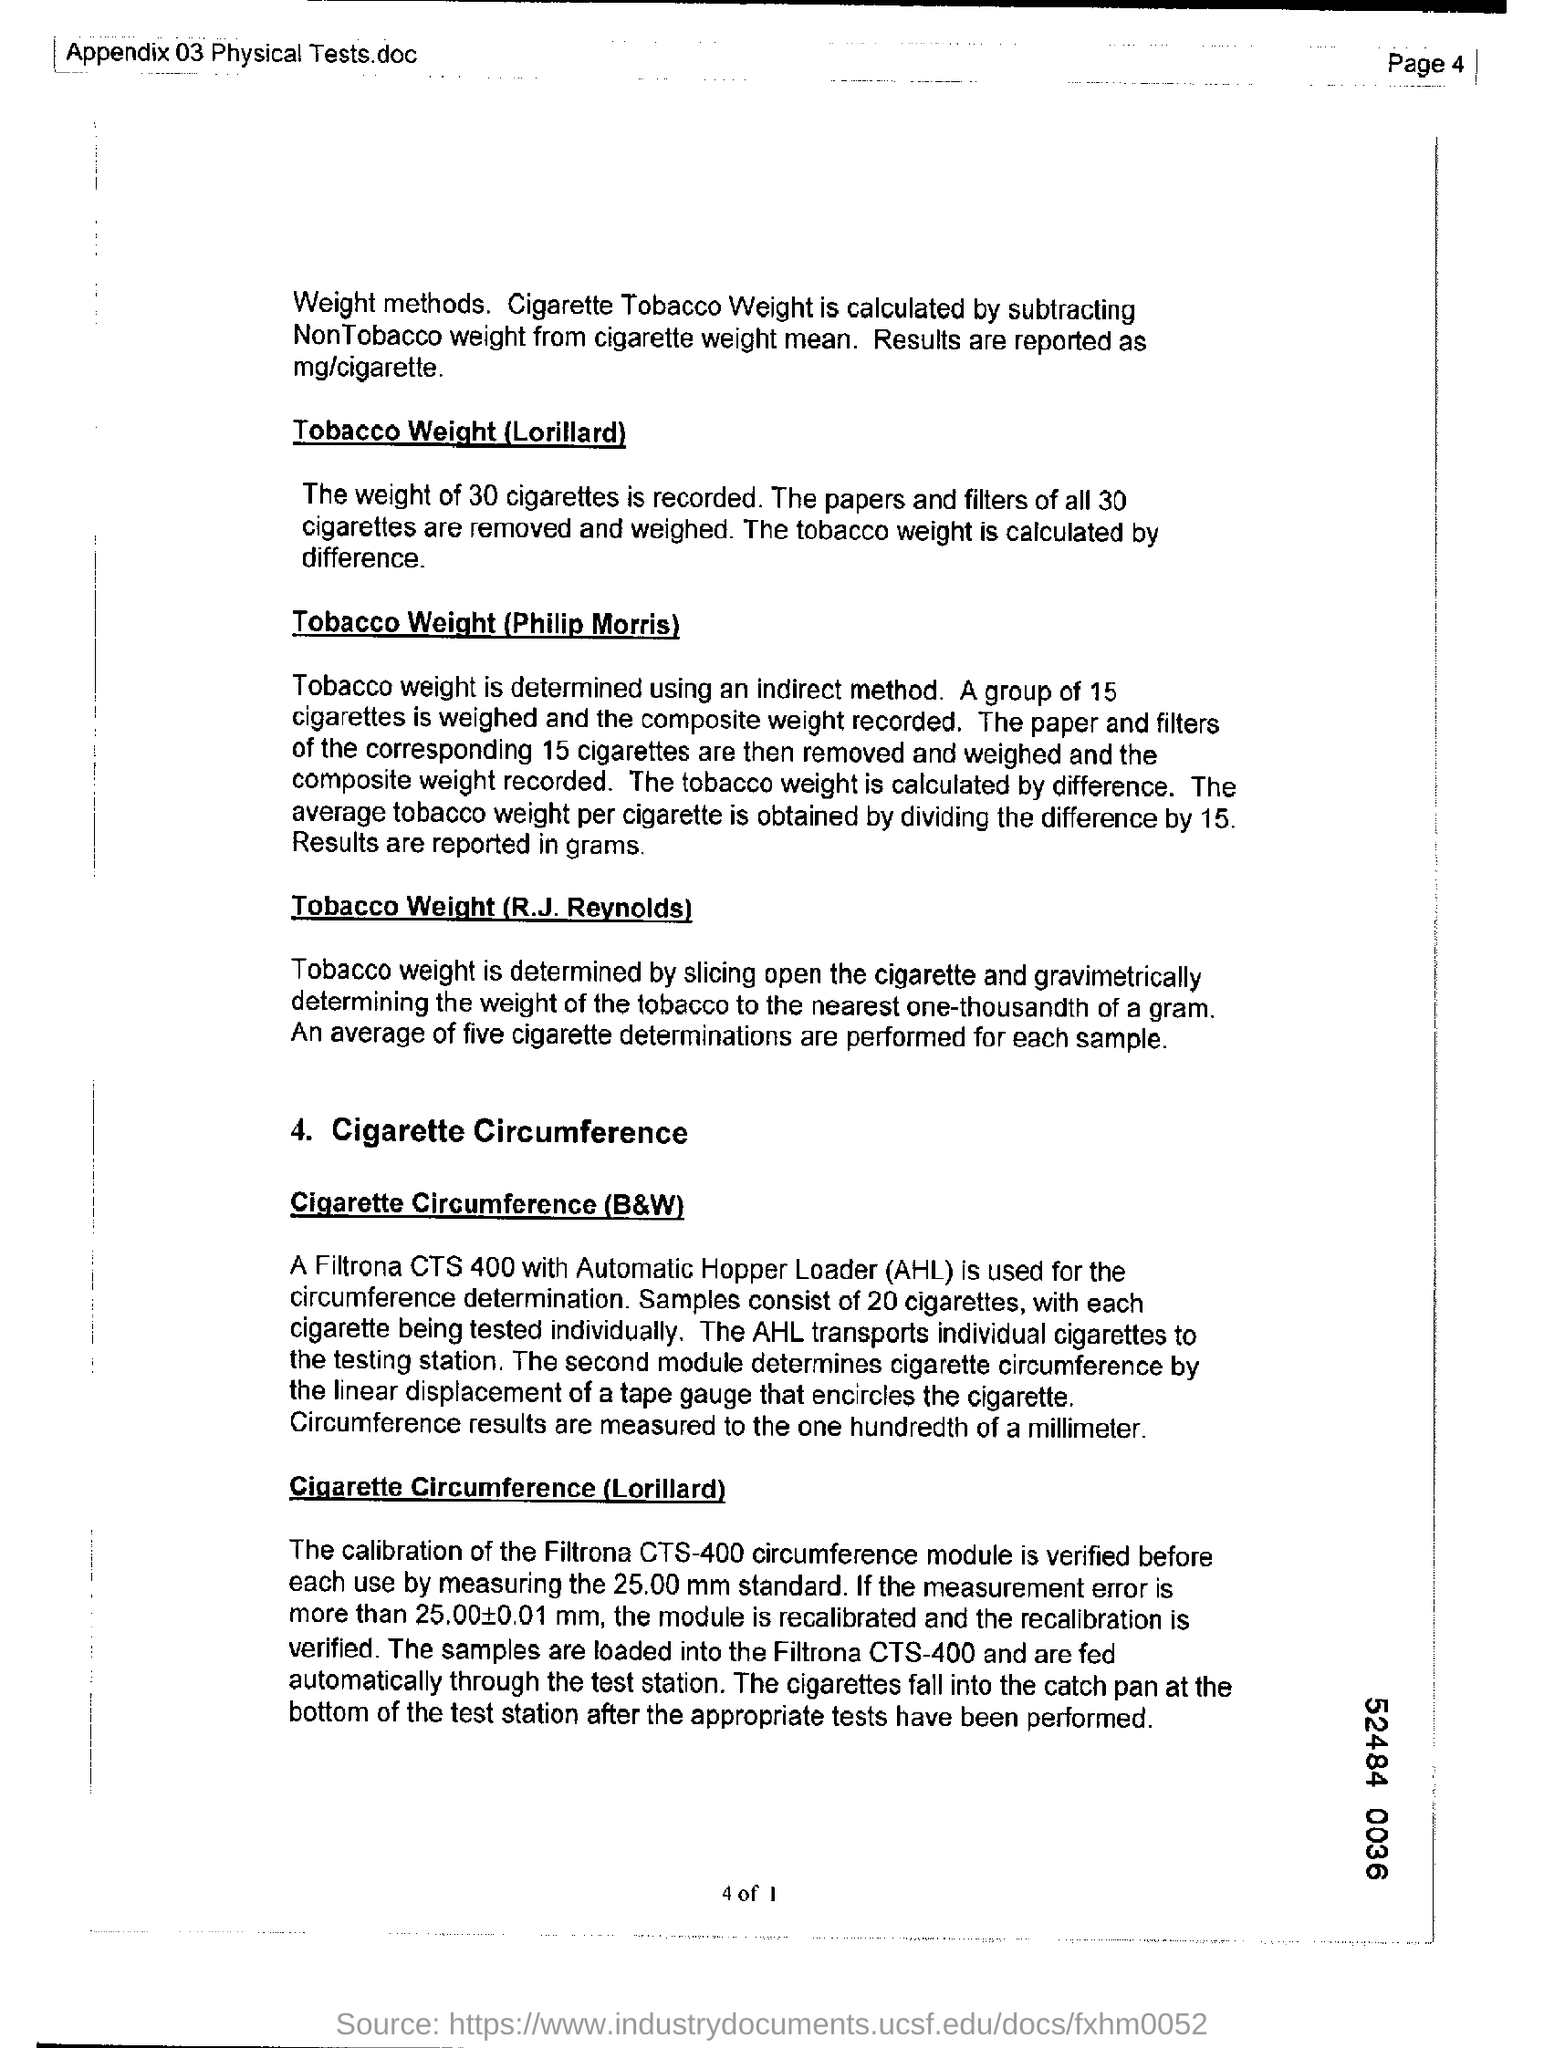What is the expansion of AHL?
Your answer should be compact. Automatic Hopper Loader. What is the page number?
Offer a terse response. 4. 